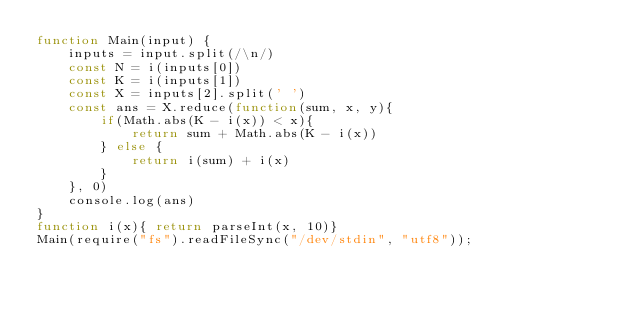Convert code to text. <code><loc_0><loc_0><loc_500><loc_500><_JavaScript_>function Main(input) {
    inputs = input.split(/\n/)
    const N = i(inputs[0])
    const K = i(inputs[1])
    const X = inputs[2].split(' ')
    const ans = X.reduce(function(sum, x, y){
        if(Math.abs(K - i(x)) < x){
            return sum + Math.abs(K - i(x))
        } else {
            return i(sum) + i(x)
        }
    }, 0)
    console.log(ans)
}
function i(x){ return parseInt(x, 10)}
Main(require("fs").readFileSync("/dev/stdin", "utf8"));</code> 